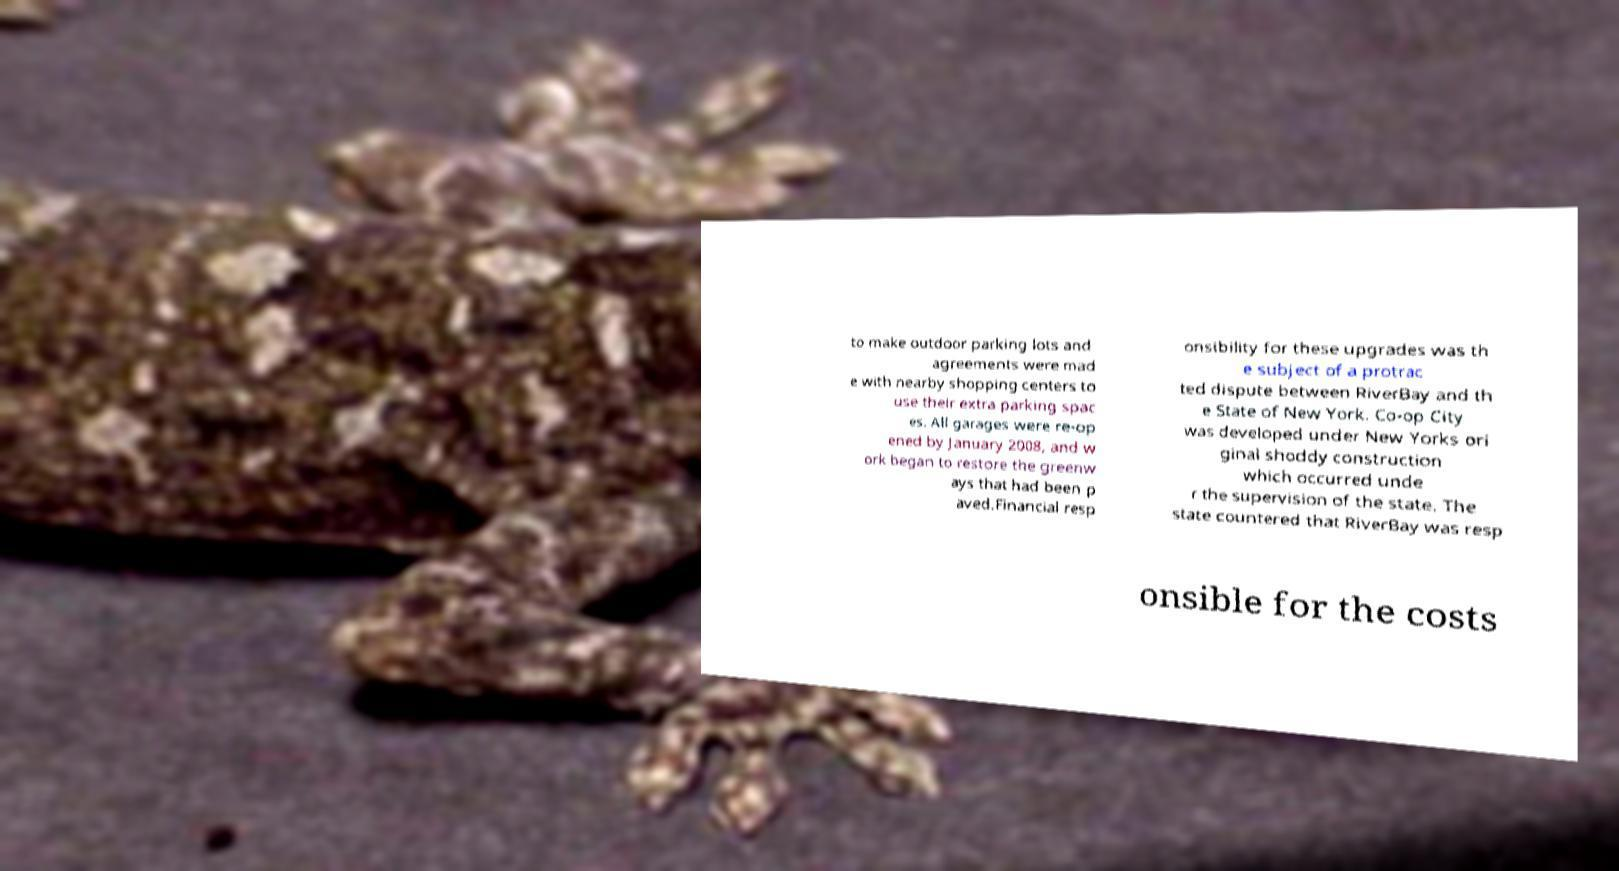There's text embedded in this image that I need extracted. Can you transcribe it verbatim? to make outdoor parking lots and agreements were mad e with nearby shopping centers to use their extra parking spac es. All garages were re-op ened by January 2008, and w ork began to restore the greenw ays that had been p aved.Financial resp onsibility for these upgrades was th e subject of a protrac ted dispute between RiverBay and th e State of New York. Co-op City was developed under New Yorks ori ginal shoddy construction which occurred unde r the supervision of the state. The state countered that RiverBay was resp onsible for the costs 